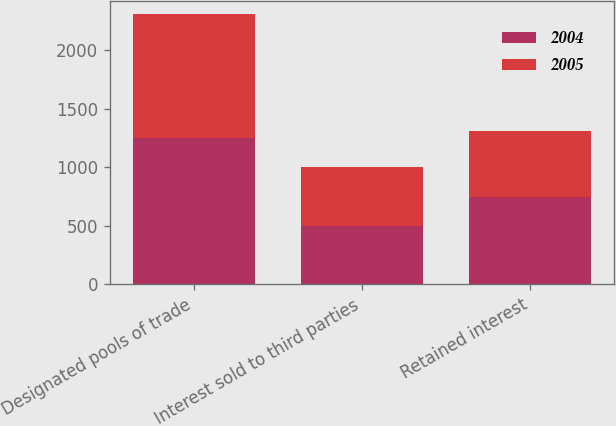Convert chart to OTSL. <chart><loc_0><loc_0><loc_500><loc_500><stacked_bar_chart><ecel><fcel>Designated pools of trade<fcel>Interest sold to third parties<fcel>Retained interest<nl><fcel>2004<fcel>1251<fcel>500<fcel>751<nl><fcel>2005<fcel>1060<fcel>500<fcel>560<nl></chart> 